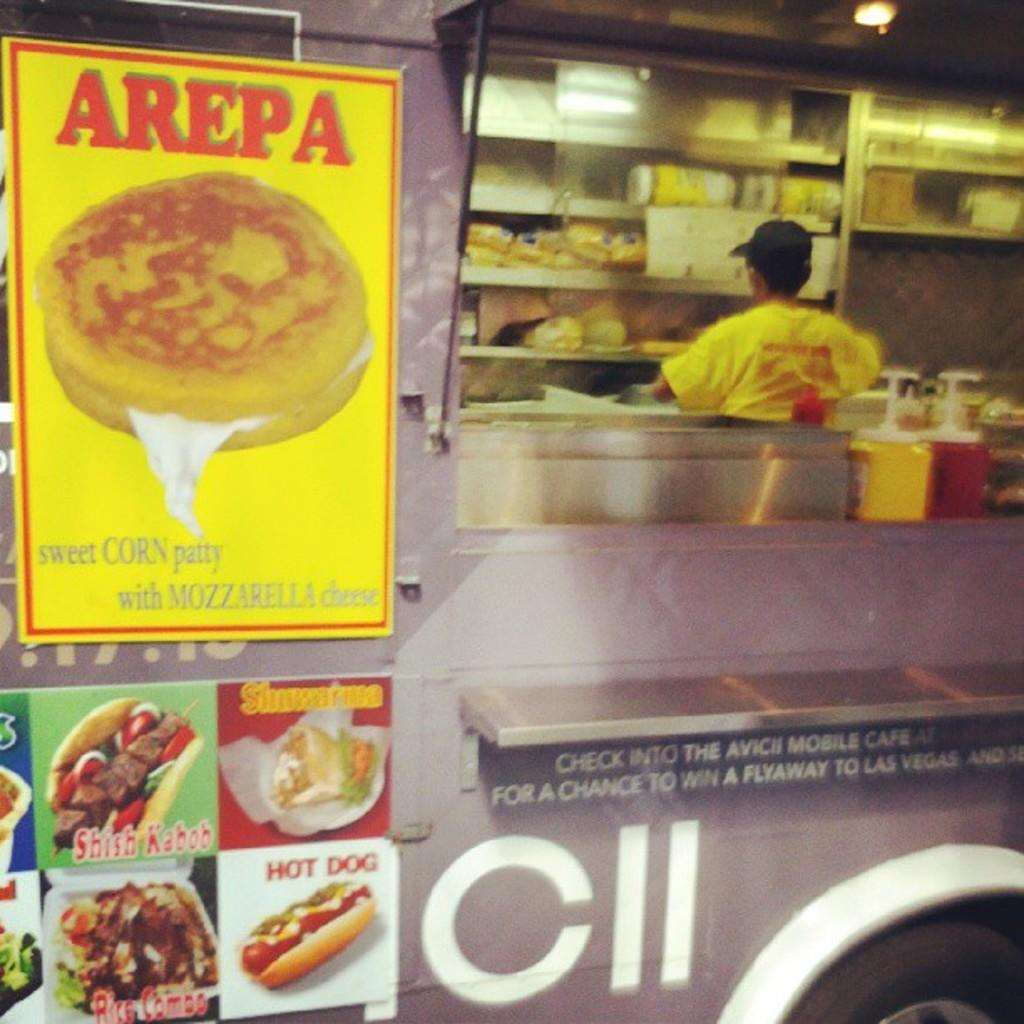What is on the vehicle in the image? There are posts on the vehicle in the image. Who or what is inside the vehicle? There is a person inside the vehicle. What else can be seen inside the vehicle? There are objects inside the vehicle. What type of pipe is visible in the image? There is no pipe present in the image. How is the earth divided in the image? There is no reference to the earth or any divisions in the image. 